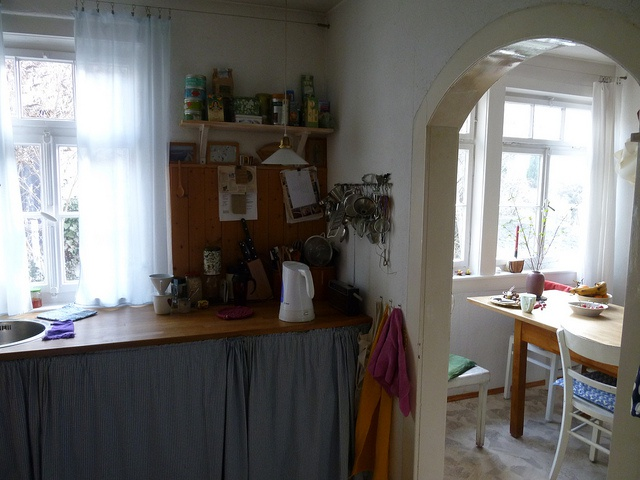Describe the objects in this image and their specific colors. I can see dining table in black, lightgray, gray, and darkgray tones, dining table in black, white, maroon, and darkgray tones, chair in black, gray, and darkgray tones, book in black tones, and chair in black and gray tones in this image. 